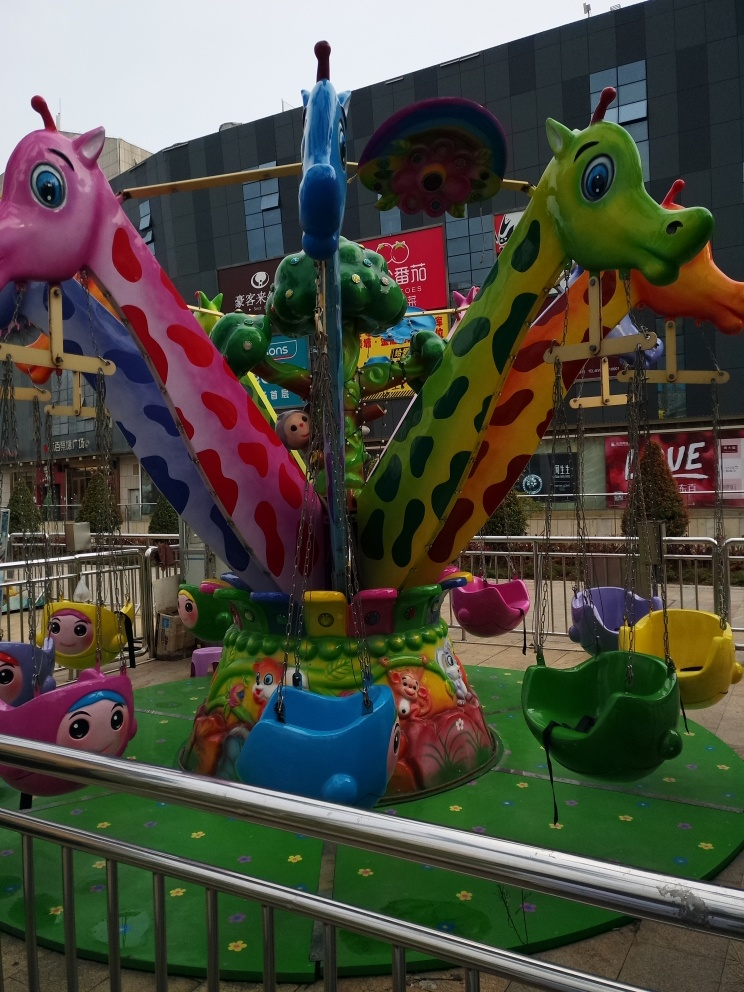Are there any focus issues in the image?
 No 